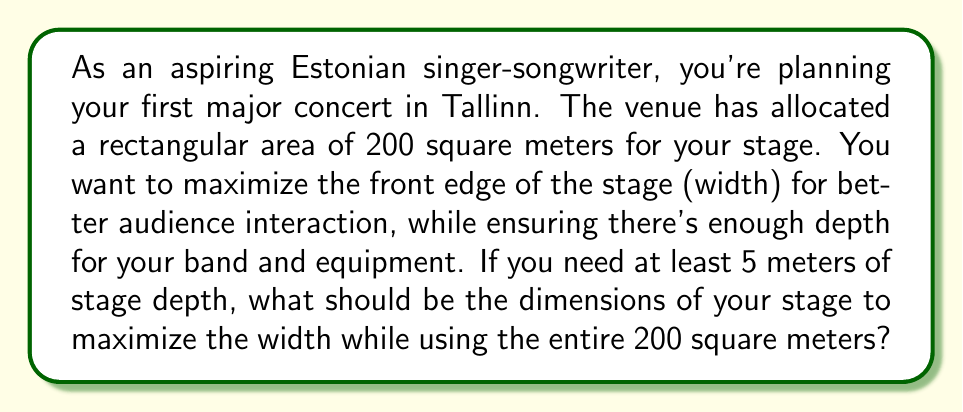Solve this math problem. Let's approach this step-by-step:

1) Let's define our variables:
   $w$ = width of the stage
   $d$ = depth of the stage

2) We know the area of the stage is 200 square meters, so we can write:
   $$ w \cdot d = 200 $$

3) We want to maximize $w$, subject to the constraint that $d \geq 5$.

4) To maximize $w$, we should use the minimum possible depth, which is 5 meters.

5) Substituting $d = 5$ into our area equation:
   $$ w \cdot 5 = 200 $$

6) Solving for $w$:
   $$ w = \frac{200}{5} = 40 $$

7) Let's verify:
   $$ 40 \cdot 5 = 200 $$
   This indeed gives us the required 200 square meters.

8) To visualize:

[asy]
unitsize(1cm);
draw((0,0)--(40,0)--(40,5)--(0,5)--cycle);
label("40 m", (20,0), S);
label("5 m", (0,2.5), W);
label("Stage", (20,2.5));
[/asy]

Therefore, to maximize the width of your stage while using the entire 200 square meters and maintaining at least 5 meters of depth, you should set up a stage that is 40 meters wide and 5 meters deep.
Answer: The optimal stage dimensions are 40 meters wide and 5 meters deep. 